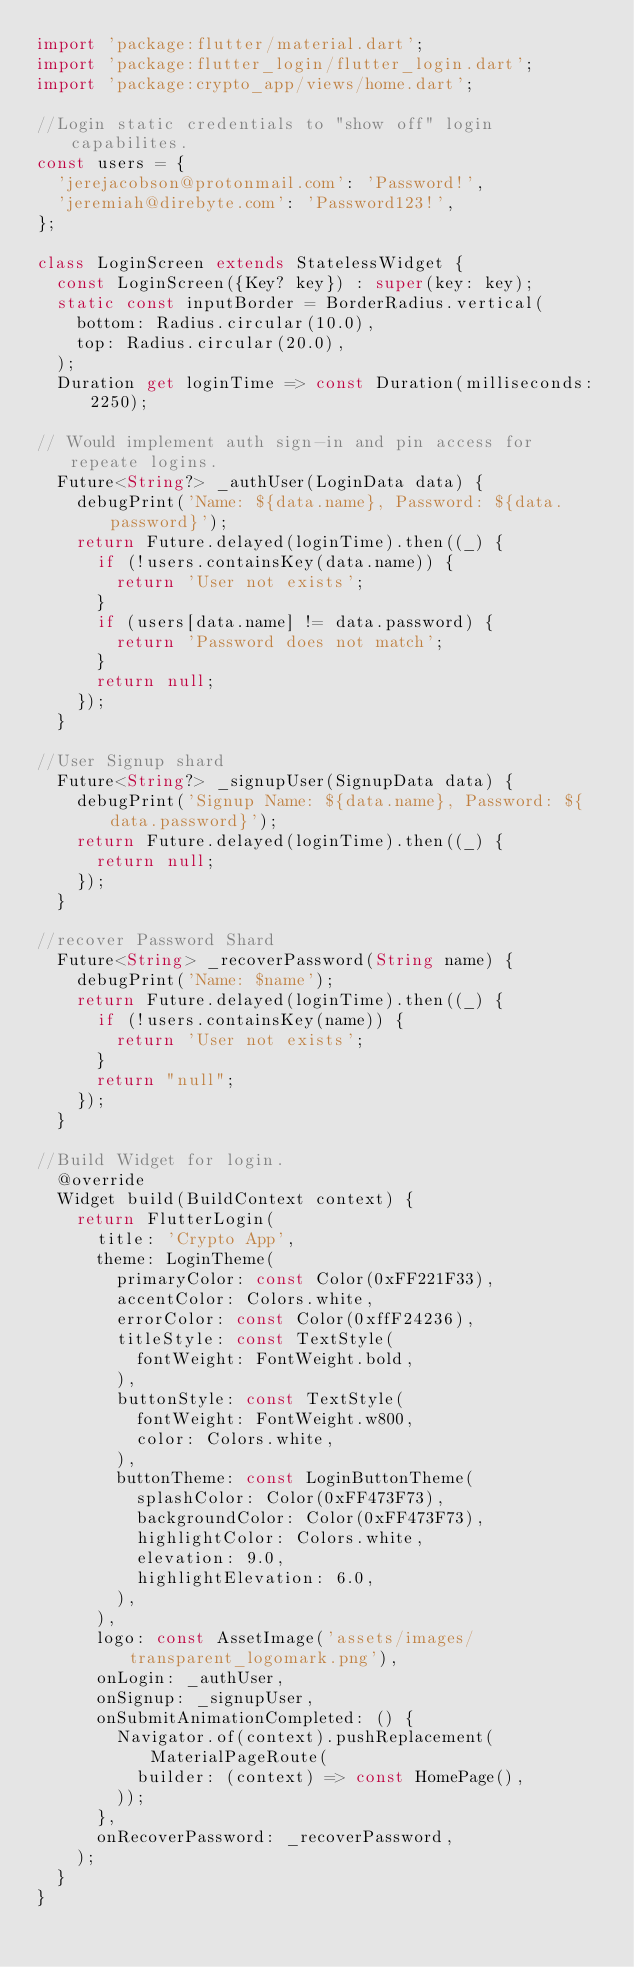<code> <loc_0><loc_0><loc_500><loc_500><_Dart_>import 'package:flutter/material.dart';
import 'package:flutter_login/flutter_login.dart';
import 'package:crypto_app/views/home.dart';

//Login static credentials to "show off" login capabilites.
const users = {
  'jerejacobson@protonmail.com': 'Password!',
  'jeremiah@direbyte.com': 'Password123!',
};

class LoginScreen extends StatelessWidget {
  const LoginScreen({Key? key}) : super(key: key);
  static const inputBorder = BorderRadius.vertical(
    bottom: Radius.circular(10.0),
    top: Radius.circular(20.0),
  );
  Duration get loginTime => const Duration(milliseconds: 2250);

// Would implement auth sign-in and pin access for repeate logins.
  Future<String?> _authUser(LoginData data) {
    debugPrint('Name: ${data.name}, Password: ${data.password}');
    return Future.delayed(loginTime).then((_) {
      if (!users.containsKey(data.name)) {
        return 'User not exists';
      }
      if (users[data.name] != data.password) {
        return 'Password does not match';
      }
      return null;
    });
  }

//User Signup shard
  Future<String?> _signupUser(SignupData data) {
    debugPrint('Signup Name: ${data.name}, Password: ${data.password}');
    return Future.delayed(loginTime).then((_) {
      return null;
    });
  }

//recover Password Shard
  Future<String> _recoverPassword(String name) {
    debugPrint('Name: $name');
    return Future.delayed(loginTime).then((_) {
      if (!users.containsKey(name)) {
        return 'User not exists';
      }
      return "null";
    });
  }

//Build Widget for login.
  @override
  Widget build(BuildContext context) {
    return FlutterLogin(
      title: 'Crypto App',
      theme: LoginTheme(
        primaryColor: const Color(0xFF221F33),
        accentColor: Colors.white,
        errorColor: const Color(0xffF24236),
        titleStyle: const TextStyle(
          fontWeight: FontWeight.bold,
        ),
        buttonStyle: const TextStyle(
          fontWeight: FontWeight.w800,
          color: Colors.white,
        ),
        buttonTheme: const LoginButtonTheme(
          splashColor: Color(0xFF473F73),
          backgroundColor: Color(0xFF473F73),
          highlightColor: Colors.white,
          elevation: 9.0,
          highlightElevation: 6.0,
        ),
      ),
      logo: const AssetImage('assets/images/transparent_logomark.png'),
      onLogin: _authUser,
      onSignup: _signupUser,
      onSubmitAnimationCompleted: () {
        Navigator.of(context).pushReplacement(MaterialPageRoute(
          builder: (context) => const HomePage(),
        ));
      },
      onRecoverPassword: _recoverPassword,
    );
  }
}
</code> 